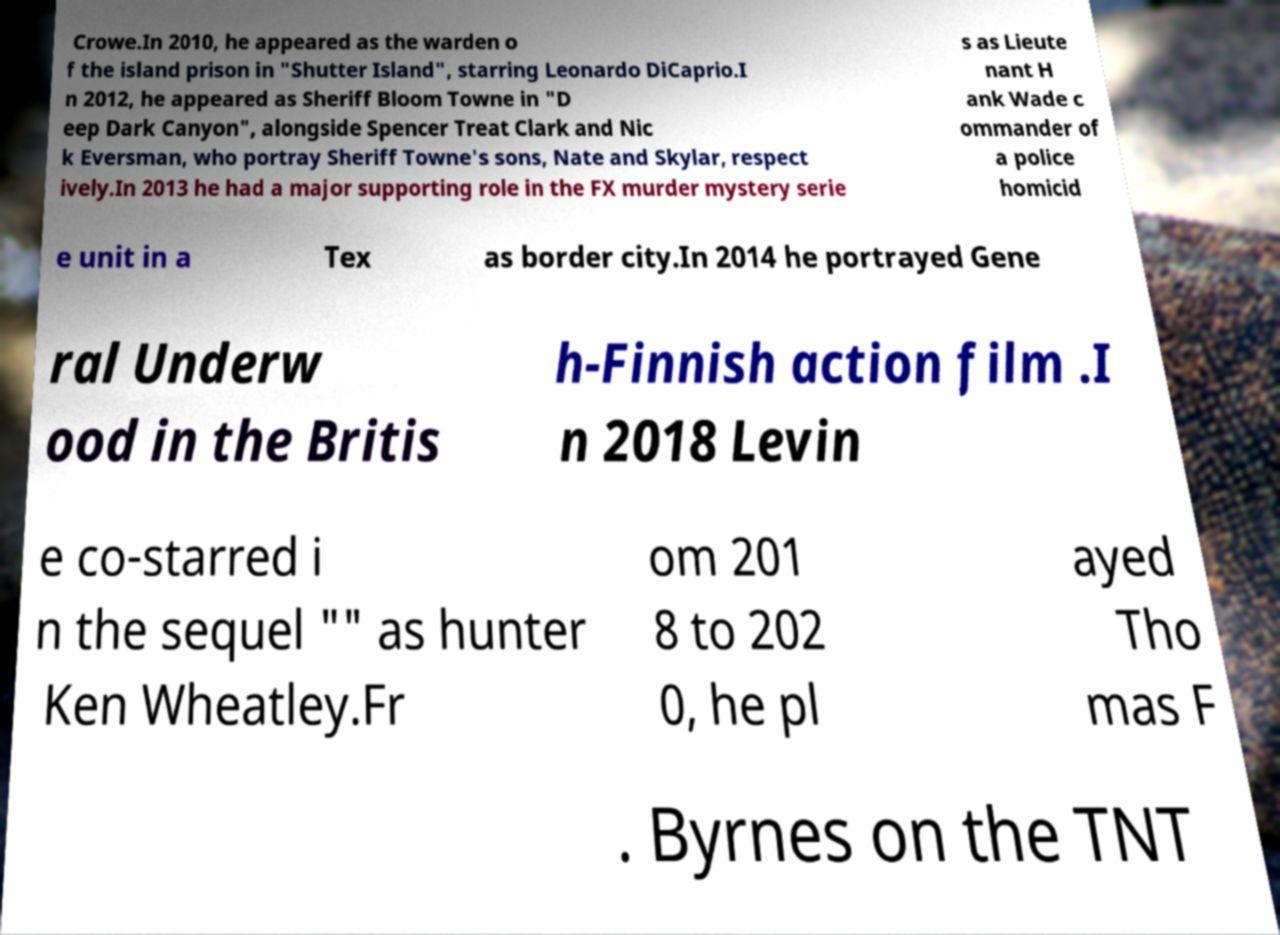Please read and relay the text visible in this image. What does it say? Crowe.In 2010, he appeared as the warden o f the island prison in "Shutter Island", starring Leonardo DiCaprio.I n 2012, he appeared as Sheriff Bloom Towne in "D eep Dark Canyon", alongside Spencer Treat Clark and Nic k Eversman, who portray Sheriff Towne's sons, Nate and Skylar, respect ively.In 2013 he had a major supporting role in the FX murder mystery serie s as Lieute nant H ank Wade c ommander of a police homicid e unit in a Tex as border city.In 2014 he portrayed Gene ral Underw ood in the Britis h-Finnish action film .I n 2018 Levin e co-starred i n the sequel "" as hunter Ken Wheatley.Fr om 201 8 to 202 0, he pl ayed Tho mas F . Byrnes on the TNT 